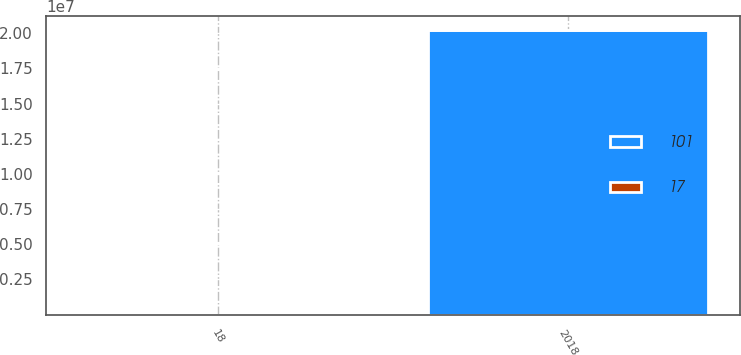Convert chart. <chart><loc_0><loc_0><loc_500><loc_500><stacked_bar_chart><ecel><fcel>2018<fcel>18<nl><fcel>17<fcel>2019<fcel>17<nl><fcel>101<fcel>2.0232e+07<fcel>101<nl></chart> 